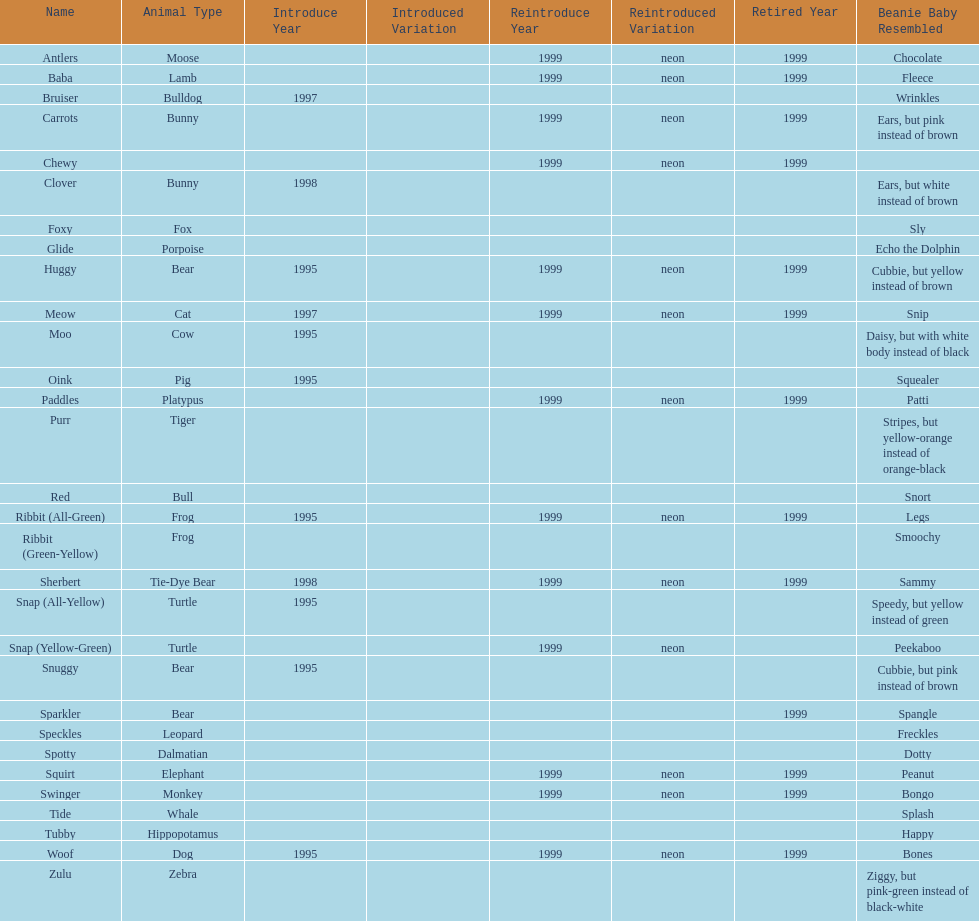Which animal type has the most pillow pals? Bear. 